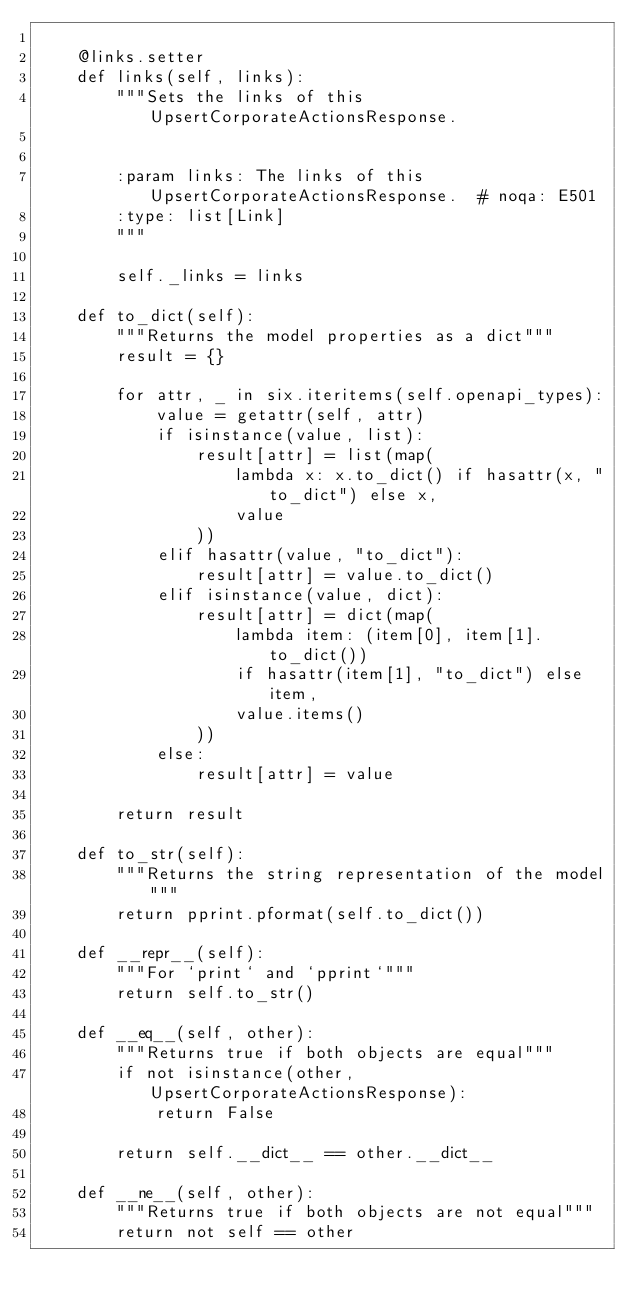Convert code to text. <code><loc_0><loc_0><loc_500><loc_500><_Python_>
    @links.setter
    def links(self, links):
        """Sets the links of this UpsertCorporateActionsResponse.


        :param links: The links of this UpsertCorporateActionsResponse.  # noqa: E501
        :type: list[Link]
        """

        self._links = links

    def to_dict(self):
        """Returns the model properties as a dict"""
        result = {}

        for attr, _ in six.iteritems(self.openapi_types):
            value = getattr(self, attr)
            if isinstance(value, list):
                result[attr] = list(map(
                    lambda x: x.to_dict() if hasattr(x, "to_dict") else x,
                    value
                ))
            elif hasattr(value, "to_dict"):
                result[attr] = value.to_dict()
            elif isinstance(value, dict):
                result[attr] = dict(map(
                    lambda item: (item[0], item[1].to_dict())
                    if hasattr(item[1], "to_dict") else item,
                    value.items()
                ))
            else:
                result[attr] = value

        return result

    def to_str(self):
        """Returns the string representation of the model"""
        return pprint.pformat(self.to_dict())

    def __repr__(self):
        """For `print` and `pprint`"""
        return self.to_str()

    def __eq__(self, other):
        """Returns true if both objects are equal"""
        if not isinstance(other, UpsertCorporateActionsResponse):
            return False

        return self.__dict__ == other.__dict__

    def __ne__(self, other):
        """Returns true if both objects are not equal"""
        return not self == other
</code> 